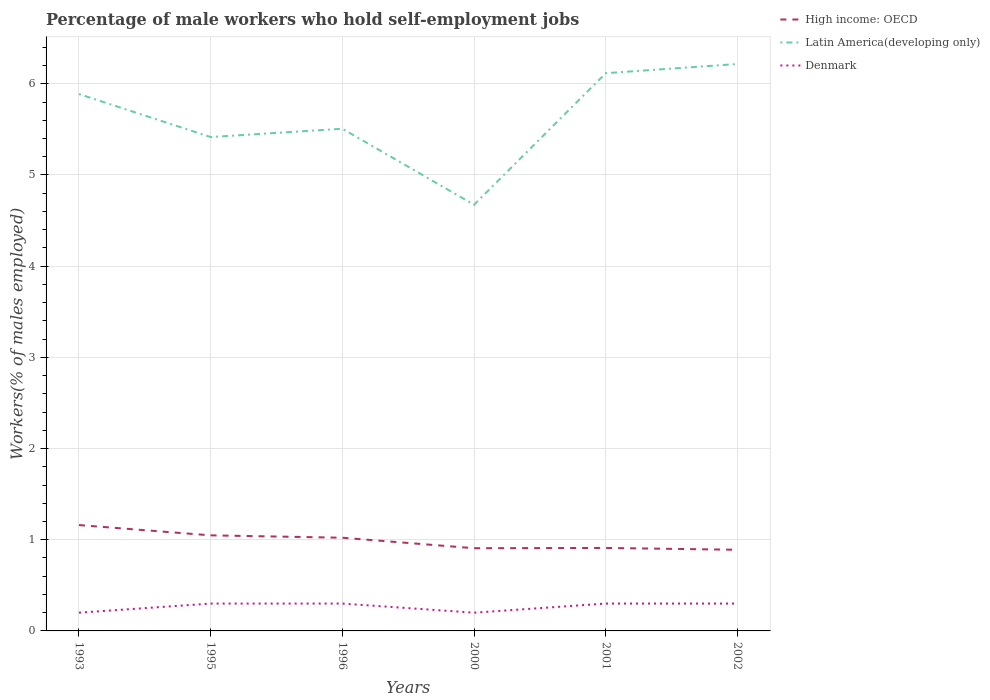How many different coloured lines are there?
Keep it short and to the point. 3. Across all years, what is the maximum percentage of self-employed male workers in Denmark?
Ensure brevity in your answer.  0.2. What is the total percentage of self-employed male workers in High income: OECD in the graph?
Provide a succinct answer. 0.11. What is the difference between the highest and the second highest percentage of self-employed male workers in Denmark?
Keep it short and to the point. 0.1. How many lines are there?
Provide a short and direct response. 3. How many years are there in the graph?
Your answer should be compact. 6. Are the values on the major ticks of Y-axis written in scientific E-notation?
Provide a short and direct response. No. Does the graph contain any zero values?
Offer a very short reply. No. Does the graph contain grids?
Offer a very short reply. Yes. How many legend labels are there?
Ensure brevity in your answer.  3. What is the title of the graph?
Your answer should be very brief. Percentage of male workers who hold self-employment jobs. What is the label or title of the Y-axis?
Offer a very short reply. Workers(% of males employed). What is the Workers(% of males employed) of High income: OECD in 1993?
Your answer should be compact. 1.16. What is the Workers(% of males employed) of Latin America(developing only) in 1993?
Provide a succinct answer. 5.89. What is the Workers(% of males employed) in Denmark in 1993?
Your answer should be compact. 0.2. What is the Workers(% of males employed) in High income: OECD in 1995?
Offer a terse response. 1.05. What is the Workers(% of males employed) of Latin America(developing only) in 1995?
Provide a short and direct response. 5.42. What is the Workers(% of males employed) of Denmark in 1995?
Provide a succinct answer. 0.3. What is the Workers(% of males employed) of High income: OECD in 1996?
Offer a very short reply. 1.02. What is the Workers(% of males employed) of Latin America(developing only) in 1996?
Your answer should be compact. 5.51. What is the Workers(% of males employed) in Denmark in 1996?
Your response must be concise. 0.3. What is the Workers(% of males employed) of High income: OECD in 2000?
Your answer should be very brief. 0.91. What is the Workers(% of males employed) of Latin America(developing only) in 2000?
Offer a very short reply. 4.67. What is the Workers(% of males employed) in Denmark in 2000?
Provide a short and direct response. 0.2. What is the Workers(% of males employed) of High income: OECD in 2001?
Your answer should be very brief. 0.91. What is the Workers(% of males employed) of Latin America(developing only) in 2001?
Make the answer very short. 6.12. What is the Workers(% of males employed) of Denmark in 2001?
Offer a terse response. 0.3. What is the Workers(% of males employed) in High income: OECD in 2002?
Offer a terse response. 0.89. What is the Workers(% of males employed) of Latin America(developing only) in 2002?
Your response must be concise. 6.22. What is the Workers(% of males employed) of Denmark in 2002?
Offer a terse response. 0.3. Across all years, what is the maximum Workers(% of males employed) of High income: OECD?
Your answer should be very brief. 1.16. Across all years, what is the maximum Workers(% of males employed) in Latin America(developing only)?
Offer a terse response. 6.22. Across all years, what is the maximum Workers(% of males employed) of Denmark?
Your answer should be very brief. 0.3. Across all years, what is the minimum Workers(% of males employed) in High income: OECD?
Offer a very short reply. 0.89. Across all years, what is the minimum Workers(% of males employed) of Latin America(developing only)?
Your answer should be compact. 4.67. Across all years, what is the minimum Workers(% of males employed) in Denmark?
Make the answer very short. 0.2. What is the total Workers(% of males employed) of High income: OECD in the graph?
Make the answer very short. 5.94. What is the total Workers(% of males employed) in Latin America(developing only) in the graph?
Provide a short and direct response. 33.82. What is the difference between the Workers(% of males employed) in High income: OECD in 1993 and that in 1995?
Make the answer very short. 0.11. What is the difference between the Workers(% of males employed) of Latin America(developing only) in 1993 and that in 1995?
Your answer should be compact. 0.47. What is the difference between the Workers(% of males employed) in Denmark in 1993 and that in 1995?
Provide a succinct answer. -0.1. What is the difference between the Workers(% of males employed) in High income: OECD in 1993 and that in 1996?
Your answer should be compact. 0.14. What is the difference between the Workers(% of males employed) in Latin America(developing only) in 1993 and that in 1996?
Your answer should be very brief. 0.38. What is the difference between the Workers(% of males employed) of High income: OECD in 1993 and that in 2000?
Your answer should be compact. 0.25. What is the difference between the Workers(% of males employed) of Latin America(developing only) in 1993 and that in 2000?
Make the answer very short. 1.21. What is the difference between the Workers(% of males employed) in High income: OECD in 1993 and that in 2001?
Make the answer very short. 0.25. What is the difference between the Workers(% of males employed) in Latin America(developing only) in 1993 and that in 2001?
Make the answer very short. -0.23. What is the difference between the Workers(% of males employed) of High income: OECD in 1993 and that in 2002?
Make the answer very short. 0.27. What is the difference between the Workers(% of males employed) of Latin America(developing only) in 1993 and that in 2002?
Ensure brevity in your answer.  -0.33. What is the difference between the Workers(% of males employed) of High income: OECD in 1995 and that in 1996?
Offer a very short reply. 0.03. What is the difference between the Workers(% of males employed) in Latin America(developing only) in 1995 and that in 1996?
Your answer should be compact. -0.09. What is the difference between the Workers(% of males employed) in Denmark in 1995 and that in 1996?
Ensure brevity in your answer.  0. What is the difference between the Workers(% of males employed) in High income: OECD in 1995 and that in 2000?
Your response must be concise. 0.14. What is the difference between the Workers(% of males employed) in Latin America(developing only) in 1995 and that in 2000?
Your response must be concise. 0.74. What is the difference between the Workers(% of males employed) in High income: OECD in 1995 and that in 2001?
Your answer should be compact. 0.14. What is the difference between the Workers(% of males employed) in Latin America(developing only) in 1995 and that in 2001?
Offer a very short reply. -0.7. What is the difference between the Workers(% of males employed) in Denmark in 1995 and that in 2001?
Make the answer very short. 0. What is the difference between the Workers(% of males employed) of High income: OECD in 1995 and that in 2002?
Keep it short and to the point. 0.16. What is the difference between the Workers(% of males employed) in Latin America(developing only) in 1995 and that in 2002?
Your answer should be compact. -0.8. What is the difference between the Workers(% of males employed) in Denmark in 1995 and that in 2002?
Provide a short and direct response. 0. What is the difference between the Workers(% of males employed) of High income: OECD in 1996 and that in 2000?
Provide a succinct answer. 0.12. What is the difference between the Workers(% of males employed) in Latin America(developing only) in 1996 and that in 2000?
Your answer should be very brief. 0.83. What is the difference between the Workers(% of males employed) in Denmark in 1996 and that in 2000?
Provide a short and direct response. 0.1. What is the difference between the Workers(% of males employed) in High income: OECD in 1996 and that in 2001?
Make the answer very short. 0.11. What is the difference between the Workers(% of males employed) of Latin America(developing only) in 1996 and that in 2001?
Keep it short and to the point. -0.61. What is the difference between the Workers(% of males employed) in High income: OECD in 1996 and that in 2002?
Provide a succinct answer. 0.13. What is the difference between the Workers(% of males employed) of Latin America(developing only) in 1996 and that in 2002?
Keep it short and to the point. -0.71. What is the difference between the Workers(% of males employed) of High income: OECD in 2000 and that in 2001?
Keep it short and to the point. -0. What is the difference between the Workers(% of males employed) in Latin America(developing only) in 2000 and that in 2001?
Keep it short and to the point. -1.44. What is the difference between the Workers(% of males employed) of High income: OECD in 2000 and that in 2002?
Offer a terse response. 0.02. What is the difference between the Workers(% of males employed) of Latin America(developing only) in 2000 and that in 2002?
Provide a short and direct response. -1.54. What is the difference between the Workers(% of males employed) of Denmark in 2000 and that in 2002?
Provide a succinct answer. -0.1. What is the difference between the Workers(% of males employed) in High income: OECD in 2001 and that in 2002?
Provide a succinct answer. 0.02. What is the difference between the Workers(% of males employed) of Latin America(developing only) in 2001 and that in 2002?
Your response must be concise. -0.1. What is the difference between the Workers(% of males employed) of Denmark in 2001 and that in 2002?
Provide a succinct answer. 0. What is the difference between the Workers(% of males employed) in High income: OECD in 1993 and the Workers(% of males employed) in Latin America(developing only) in 1995?
Give a very brief answer. -4.25. What is the difference between the Workers(% of males employed) of High income: OECD in 1993 and the Workers(% of males employed) of Denmark in 1995?
Your answer should be compact. 0.86. What is the difference between the Workers(% of males employed) of Latin America(developing only) in 1993 and the Workers(% of males employed) of Denmark in 1995?
Give a very brief answer. 5.59. What is the difference between the Workers(% of males employed) of High income: OECD in 1993 and the Workers(% of males employed) of Latin America(developing only) in 1996?
Give a very brief answer. -4.35. What is the difference between the Workers(% of males employed) in High income: OECD in 1993 and the Workers(% of males employed) in Denmark in 1996?
Provide a short and direct response. 0.86. What is the difference between the Workers(% of males employed) of Latin America(developing only) in 1993 and the Workers(% of males employed) of Denmark in 1996?
Offer a very short reply. 5.59. What is the difference between the Workers(% of males employed) of High income: OECD in 1993 and the Workers(% of males employed) of Latin America(developing only) in 2000?
Provide a short and direct response. -3.51. What is the difference between the Workers(% of males employed) in High income: OECD in 1993 and the Workers(% of males employed) in Denmark in 2000?
Your response must be concise. 0.96. What is the difference between the Workers(% of males employed) in Latin America(developing only) in 1993 and the Workers(% of males employed) in Denmark in 2000?
Provide a succinct answer. 5.69. What is the difference between the Workers(% of males employed) in High income: OECD in 1993 and the Workers(% of males employed) in Latin America(developing only) in 2001?
Offer a very short reply. -4.96. What is the difference between the Workers(% of males employed) of High income: OECD in 1993 and the Workers(% of males employed) of Denmark in 2001?
Your response must be concise. 0.86. What is the difference between the Workers(% of males employed) of Latin America(developing only) in 1993 and the Workers(% of males employed) of Denmark in 2001?
Offer a terse response. 5.59. What is the difference between the Workers(% of males employed) in High income: OECD in 1993 and the Workers(% of males employed) in Latin America(developing only) in 2002?
Provide a short and direct response. -5.06. What is the difference between the Workers(% of males employed) in High income: OECD in 1993 and the Workers(% of males employed) in Denmark in 2002?
Provide a short and direct response. 0.86. What is the difference between the Workers(% of males employed) in Latin America(developing only) in 1993 and the Workers(% of males employed) in Denmark in 2002?
Offer a very short reply. 5.59. What is the difference between the Workers(% of males employed) in High income: OECD in 1995 and the Workers(% of males employed) in Latin America(developing only) in 1996?
Your response must be concise. -4.46. What is the difference between the Workers(% of males employed) in High income: OECD in 1995 and the Workers(% of males employed) in Denmark in 1996?
Offer a very short reply. 0.75. What is the difference between the Workers(% of males employed) in Latin America(developing only) in 1995 and the Workers(% of males employed) in Denmark in 1996?
Your response must be concise. 5.12. What is the difference between the Workers(% of males employed) of High income: OECD in 1995 and the Workers(% of males employed) of Latin America(developing only) in 2000?
Ensure brevity in your answer.  -3.63. What is the difference between the Workers(% of males employed) of High income: OECD in 1995 and the Workers(% of males employed) of Denmark in 2000?
Keep it short and to the point. 0.85. What is the difference between the Workers(% of males employed) of Latin America(developing only) in 1995 and the Workers(% of males employed) of Denmark in 2000?
Your answer should be compact. 5.22. What is the difference between the Workers(% of males employed) of High income: OECD in 1995 and the Workers(% of males employed) of Latin America(developing only) in 2001?
Offer a terse response. -5.07. What is the difference between the Workers(% of males employed) in High income: OECD in 1995 and the Workers(% of males employed) in Denmark in 2001?
Offer a terse response. 0.75. What is the difference between the Workers(% of males employed) in Latin America(developing only) in 1995 and the Workers(% of males employed) in Denmark in 2001?
Your answer should be very brief. 5.12. What is the difference between the Workers(% of males employed) of High income: OECD in 1995 and the Workers(% of males employed) of Latin America(developing only) in 2002?
Your answer should be very brief. -5.17. What is the difference between the Workers(% of males employed) in High income: OECD in 1995 and the Workers(% of males employed) in Denmark in 2002?
Ensure brevity in your answer.  0.75. What is the difference between the Workers(% of males employed) in Latin America(developing only) in 1995 and the Workers(% of males employed) in Denmark in 2002?
Your answer should be compact. 5.12. What is the difference between the Workers(% of males employed) of High income: OECD in 1996 and the Workers(% of males employed) of Latin America(developing only) in 2000?
Ensure brevity in your answer.  -3.65. What is the difference between the Workers(% of males employed) of High income: OECD in 1996 and the Workers(% of males employed) of Denmark in 2000?
Ensure brevity in your answer.  0.82. What is the difference between the Workers(% of males employed) of Latin America(developing only) in 1996 and the Workers(% of males employed) of Denmark in 2000?
Your response must be concise. 5.31. What is the difference between the Workers(% of males employed) in High income: OECD in 1996 and the Workers(% of males employed) in Latin America(developing only) in 2001?
Keep it short and to the point. -5.09. What is the difference between the Workers(% of males employed) of High income: OECD in 1996 and the Workers(% of males employed) of Denmark in 2001?
Give a very brief answer. 0.72. What is the difference between the Workers(% of males employed) in Latin America(developing only) in 1996 and the Workers(% of males employed) in Denmark in 2001?
Your answer should be very brief. 5.21. What is the difference between the Workers(% of males employed) in High income: OECD in 1996 and the Workers(% of males employed) in Latin America(developing only) in 2002?
Ensure brevity in your answer.  -5.19. What is the difference between the Workers(% of males employed) of High income: OECD in 1996 and the Workers(% of males employed) of Denmark in 2002?
Offer a very short reply. 0.72. What is the difference between the Workers(% of males employed) of Latin America(developing only) in 1996 and the Workers(% of males employed) of Denmark in 2002?
Offer a very short reply. 5.21. What is the difference between the Workers(% of males employed) of High income: OECD in 2000 and the Workers(% of males employed) of Latin America(developing only) in 2001?
Your answer should be very brief. -5.21. What is the difference between the Workers(% of males employed) in High income: OECD in 2000 and the Workers(% of males employed) in Denmark in 2001?
Ensure brevity in your answer.  0.61. What is the difference between the Workers(% of males employed) of Latin America(developing only) in 2000 and the Workers(% of males employed) of Denmark in 2001?
Offer a terse response. 4.37. What is the difference between the Workers(% of males employed) of High income: OECD in 2000 and the Workers(% of males employed) of Latin America(developing only) in 2002?
Make the answer very short. -5.31. What is the difference between the Workers(% of males employed) in High income: OECD in 2000 and the Workers(% of males employed) in Denmark in 2002?
Ensure brevity in your answer.  0.61. What is the difference between the Workers(% of males employed) in Latin America(developing only) in 2000 and the Workers(% of males employed) in Denmark in 2002?
Your answer should be compact. 4.37. What is the difference between the Workers(% of males employed) in High income: OECD in 2001 and the Workers(% of males employed) in Latin America(developing only) in 2002?
Offer a very short reply. -5.31. What is the difference between the Workers(% of males employed) of High income: OECD in 2001 and the Workers(% of males employed) of Denmark in 2002?
Give a very brief answer. 0.61. What is the difference between the Workers(% of males employed) in Latin America(developing only) in 2001 and the Workers(% of males employed) in Denmark in 2002?
Provide a succinct answer. 5.82. What is the average Workers(% of males employed) in Latin America(developing only) per year?
Ensure brevity in your answer.  5.64. What is the average Workers(% of males employed) of Denmark per year?
Offer a terse response. 0.27. In the year 1993, what is the difference between the Workers(% of males employed) in High income: OECD and Workers(% of males employed) in Latin America(developing only)?
Offer a terse response. -4.73. In the year 1993, what is the difference between the Workers(% of males employed) of High income: OECD and Workers(% of males employed) of Denmark?
Your response must be concise. 0.96. In the year 1993, what is the difference between the Workers(% of males employed) in Latin America(developing only) and Workers(% of males employed) in Denmark?
Your answer should be compact. 5.69. In the year 1995, what is the difference between the Workers(% of males employed) in High income: OECD and Workers(% of males employed) in Latin America(developing only)?
Keep it short and to the point. -4.37. In the year 1995, what is the difference between the Workers(% of males employed) of High income: OECD and Workers(% of males employed) of Denmark?
Provide a short and direct response. 0.75. In the year 1995, what is the difference between the Workers(% of males employed) in Latin America(developing only) and Workers(% of males employed) in Denmark?
Give a very brief answer. 5.12. In the year 1996, what is the difference between the Workers(% of males employed) of High income: OECD and Workers(% of males employed) of Latin America(developing only)?
Your answer should be very brief. -4.48. In the year 1996, what is the difference between the Workers(% of males employed) in High income: OECD and Workers(% of males employed) in Denmark?
Your answer should be very brief. 0.72. In the year 1996, what is the difference between the Workers(% of males employed) of Latin America(developing only) and Workers(% of males employed) of Denmark?
Your response must be concise. 5.21. In the year 2000, what is the difference between the Workers(% of males employed) in High income: OECD and Workers(% of males employed) in Latin America(developing only)?
Make the answer very short. -3.77. In the year 2000, what is the difference between the Workers(% of males employed) of High income: OECD and Workers(% of males employed) of Denmark?
Your answer should be very brief. 0.71. In the year 2000, what is the difference between the Workers(% of males employed) of Latin America(developing only) and Workers(% of males employed) of Denmark?
Keep it short and to the point. 4.47. In the year 2001, what is the difference between the Workers(% of males employed) in High income: OECD and Workers(% of males employed) in Latin America(developing only)?
Provide a short and direct response. -5.21. In the year 2001, what is the difference between the Workers(% of males employed) of High income: OECD and Workers(% of males employed) of Denmark?
Ensure brevity in your answer.  0.61. In the year 2001, what is the difference between the Workers(% of males employed) of Latin America(developing only) and Workers(% of males employed) of Denmark?
Offer a very short reply. 5.82. In the year 2002, what is the difference between the Workers(% of males employed) of High income: OECD and Workers(% of males employed) of Latin America(developing only)?
Your response must be concise. -5.33. In the year 2002, what is the difference between the Workers(% of males employed) in High income: OECD and Workers(% of males employed) in Denmark?
Your response must be concise. 0.59. In the year 2002, what is the difference between the Workers(% of males employed) of Latin America(developing only) and Workers(% of males employed) of Denmark?
Keep it short and to the point. 5.92. What is the ratio of the Workers(% of males employed) of High income: OECD in 1993 to that in 1995?
Give a very brief answer. 1.11. What is the ratio of the Workers(% of males employed) in Latin America(developing only) in 1993 to that in 1995?
Provide a short and direct response. 1.09. What is the ratio of the Workers(% of males employed) in High income: OECD in 1993 to that in 1996?
Provide a short and direct response. 1.14. What is the ratio of the Workers(% of males employed) in Latin America(developing only) in 1993 to that in 1996?
Offer a very short reply. 1.07. What is the ratio of the Workers(% of males employed) of High income: OECD in 1993 to that in 2000?
Provide a succinct answer. 1.28. What is the ratio of the Workers(% of males employed) of Latin America(developing only) in 1993 to that in 2000?
Offer a terse response. 1.26. What is the ratio of the Workers(% of males employed) in High income: OECD in 1993 to that in 2001?
Give a very brief answer. 1.28. What is the ratio of the Workers(% of males employed) of Latin America(developing only) in 1993 to that in 2001?
Your response must be concise. 0.96. What is the ratio of the Workers(% of males employed) in High income: OECD in 1993 to that in 2002?
Provide a short and direct response. 1.3. What is the ratio of the Workers(% of males employed) of Latin America(developing only) in 1993 to that in 2002?
Your response must be concise. 0.95. What is the ratio of the Workers(% of males employed) in Denmark in 1993 to that in 2002?
Give a very brief answer. 0.67. What is the ratio of the Workers(% of males employed) of High income: OECD in 1995 to that in 1996?
Provide a short and direct response. 1.03. What is the ratio of the Workers(% of males employed) in Latin America(developing only) in 1995 to that in 1996?
Your answer should be very brief. 0.98. What is the ratio of the Workers(% of males employed) in High income: OECD in 1995 to that in 2000?
Offer a very short reply. 1.16. What is the ratio of the Workers(% of males employed) in Latin America(developing only) in 1995 to that in 2000?
Give a very brief answer. 1.16. What is the ratio of the Workers(% of males employed) of High income: OECD in 1995 to that in 2001?
Provide a short and direct response. 1.15. What is the ratio of the Workers(% of males employed) in Latin America(developing only) in 1995 to that in 2001?
Provide a short and direct response. 0.89. What is the ratio of the Workers(% of males employed) in Denmark in 1995 to that in 2001?
Your response must be concise. 1. What is the ratio of the Workers(% of males employed) in High income: OECD in 1995 to that in 2002?
Ensure brevity in your answer.  1.18. What is the ratio of the Workers(% of males employed) in Latin America(developing only) in 1995 to that in 2002?
Your response must be concise. 0.87. What is the ratio of the Workers(% of males employed) in High income: OECD in 1996 to that in 2000?
Offer a very short reply. 1.13. What is the ratio of the Workers(% of males employed) in Latin America(developing only) in 1996 to that in 2000?
Your answer should be compact. 1.18. What is the ratio of the Workers(% of males employed) in High income: OECD in 1996 to that in 2001?
Your response must be concise. 1.12. What is the ratio of the Workers(% of males employed) of Latin America(developing only) in 1996 to that in 2001?
Offer a terse response. 0.9. What is the ratio of the Workers(% of males employed) in High income: OECD in 1996 to that in 2002?
Make the answer very short. 1.15. What is the ratio of the Workers(% of males employed) of Latin America(developing only) in 1996 to that in 2002?
Offer a very short reply. 0.89. What is the ratio of the Workers(% of males employed) in Latin America(developing only) in 2000 to that in 2001?
Your response must be concise. 0.76. What is the ratio of the Workers(% of males employed) in High income: OECD in 2000 to that in 2002?
Provide a short and direct response. 1.02. What is the ratio of the Workers(% of males employed) in Latin America(developing only) in 2000 to that in 2002?
Ensure brevity in your answer.  0.75. What is the ratio of the Workers(% of males employed) of Denmark in 2000 to that in 2002?
Give a very brief answer. 0.67. What is the ratio of the Workers(% of males employed) of High income: OECD in 2001 to that in 2002?
Provide a short and direct response. 1.02. What is the ratio of the Workers(% of males employed) of Latin America(developing only) in 2001 to that in 2002?
Your answer should be very brief. 0.98. What is the difference between the highest and the second highest Workers(% of males employed) of High income: OECD?
Provide a succinct answer. 0.11. What is the difference between the highest and the second highest Workers(% of males employed) of Latin America(developing only)?
Keep it short and to the point. 0.1. What is the difference between the highest and the second highest Workers(% of males employed) in Denmark?
Offer a very short reply. 0. What is the difference between the highest and the lowest Workers(% of males employed) of High income: OECD?
Give a very brief answer. 0.27. What is the difference between the highest and the lowest Workers(% of males employed) in Latin America(developing only)?
Your answer should be very brief. 1.54. 